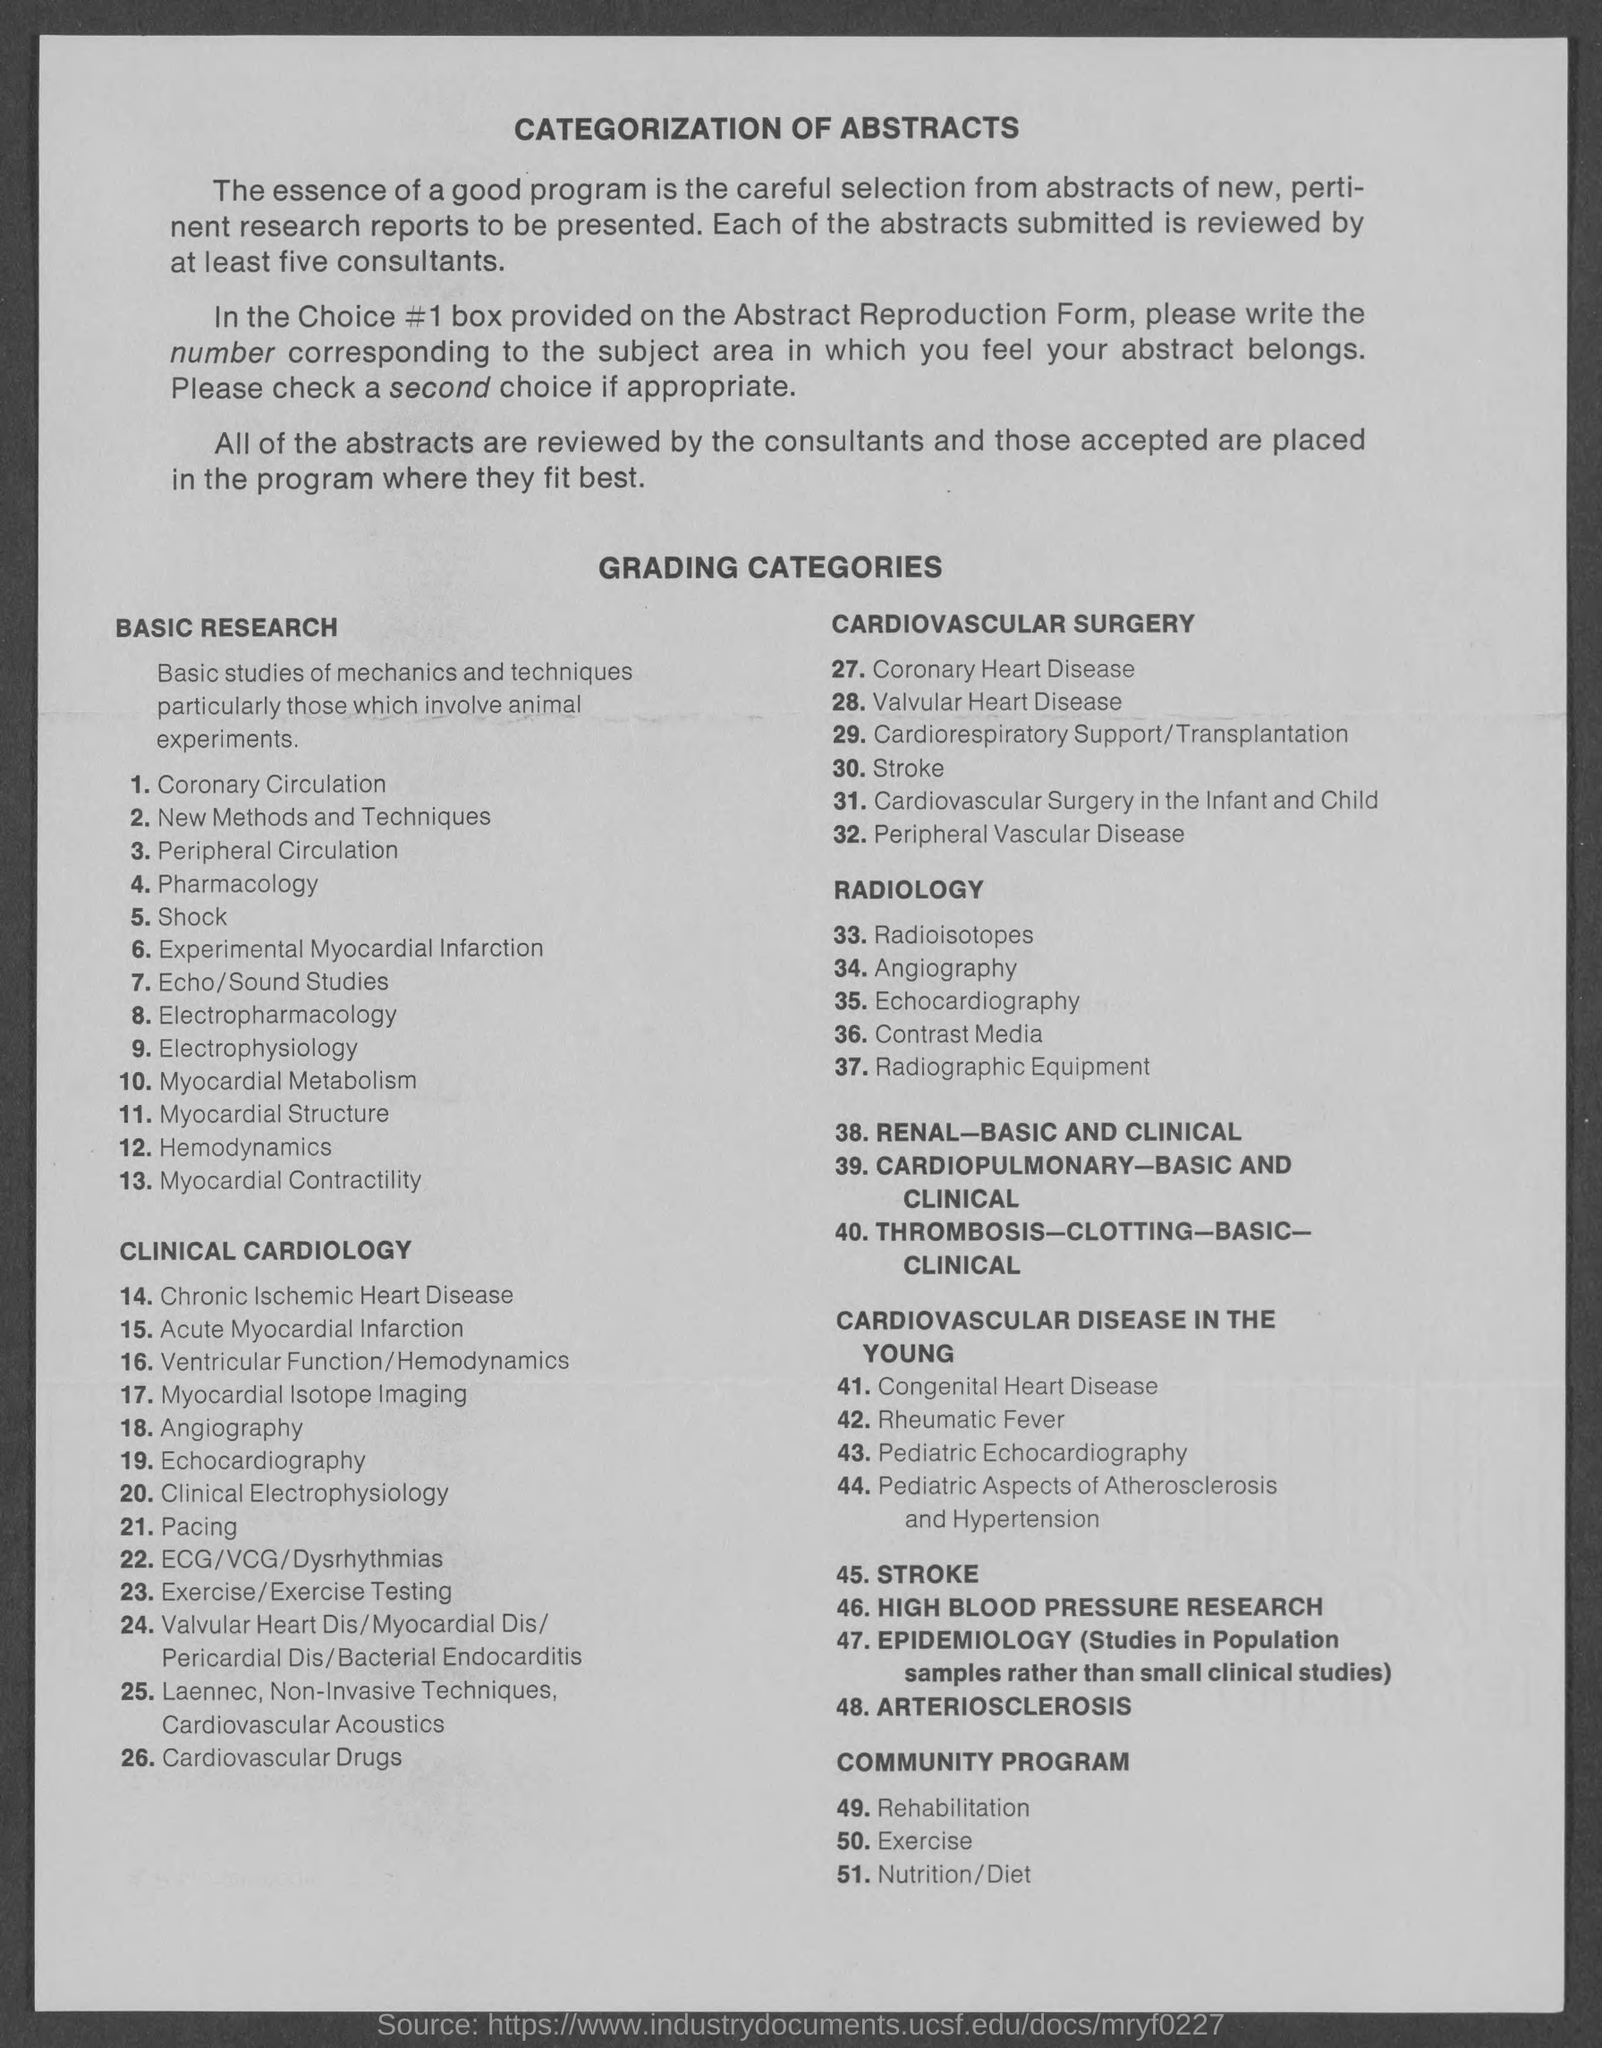What is the Title of the document?
Provide a short and direct response. Categorization of Abstracts. Who reviews the abstracts?
Give a very brief answer. Consultants. 